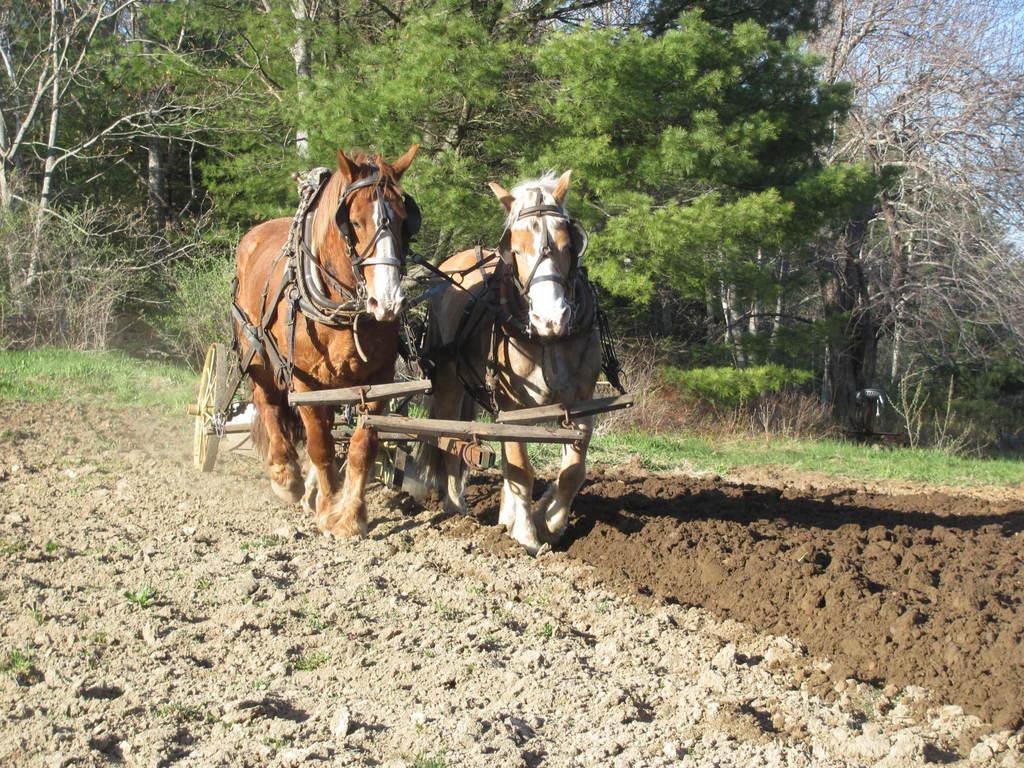Can you describe this image briefly? Front we can see two horses. Background there are a number of trees.  